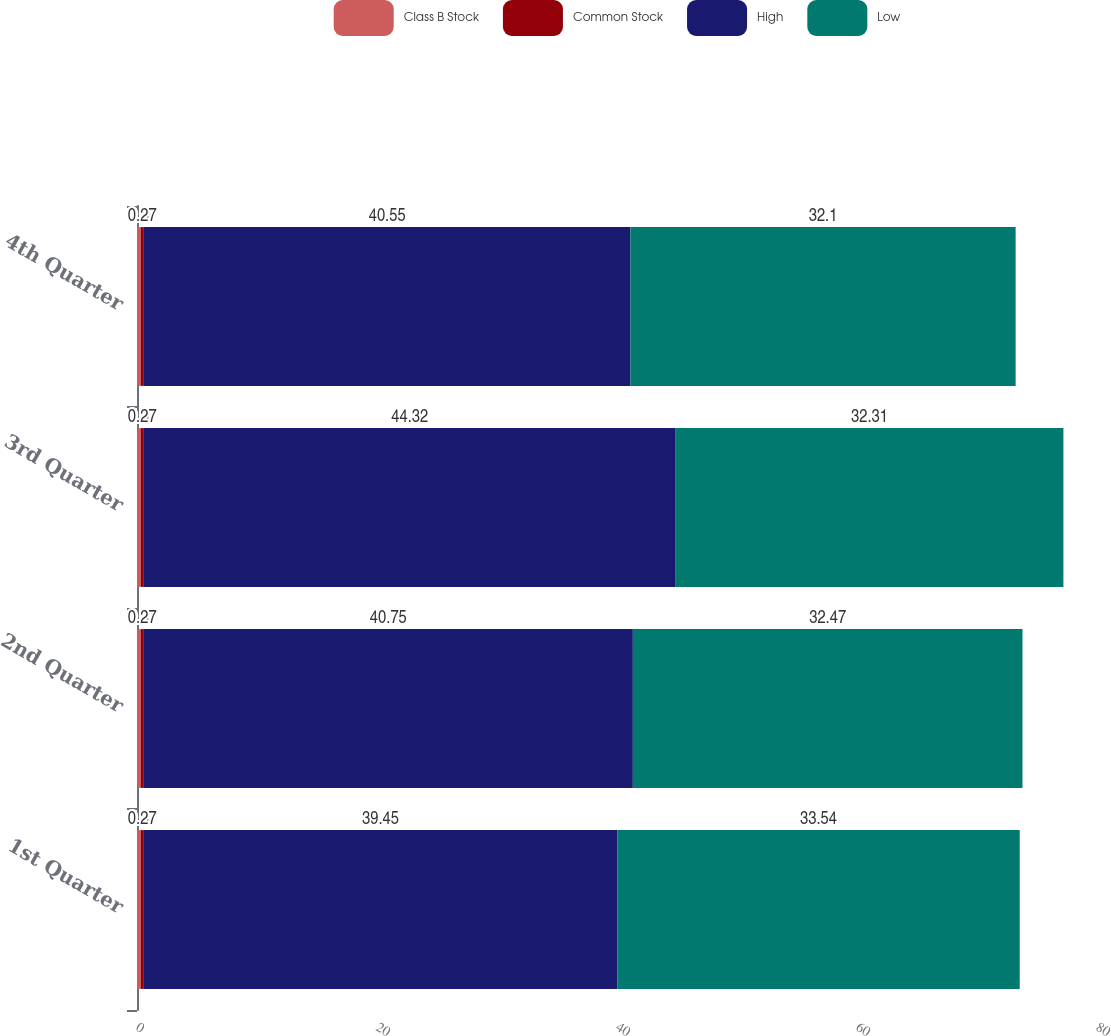Convert chart. <chart><loc_0><loc_0><loc_500><loc_500><stacked_bar_chart><ecel><fcel>1st Quarter<fcel>2nd Quarter<fcel>3rd Quarter<fcel>4th Quarter<nl><fcel>Class B Stock<fcel>0.3<fcel>0.3<fcel>0.3<fcel>0.3<nl><fcel>Common Stock<fcel>0.27<fcel>0.27<fcel>0.27<fcel>0.27<nl><fcel>High<fcel>39.45<fcel>40.75<fcel>44.32<fcel>40.55<nl><fcel>Low<fcel>33.54<fcel>32.47<fcel>32.31<fcel>32.1<nl></chart> 